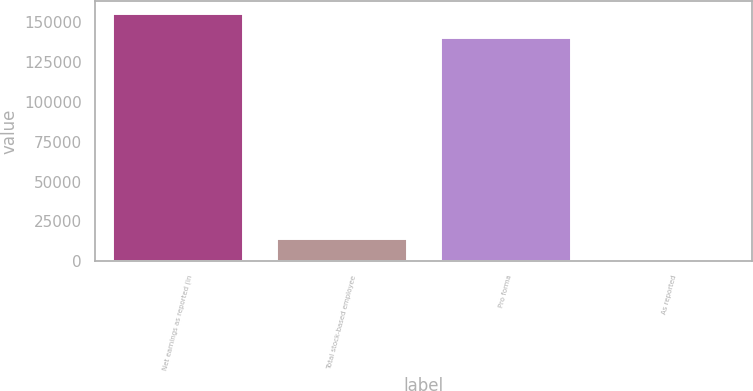Convert chart to OTSL. <chart><loc_0><loc_0><loc_500><loc_500><bar_chart><fcel>Net earnings as reported (in<fcel>Total stock-based employee<fcel>Pro forma<fcel>As reported<nl><fcel>155636<fcel>14626.4<fcel>141010<fcel>0.91<nl></chart> 